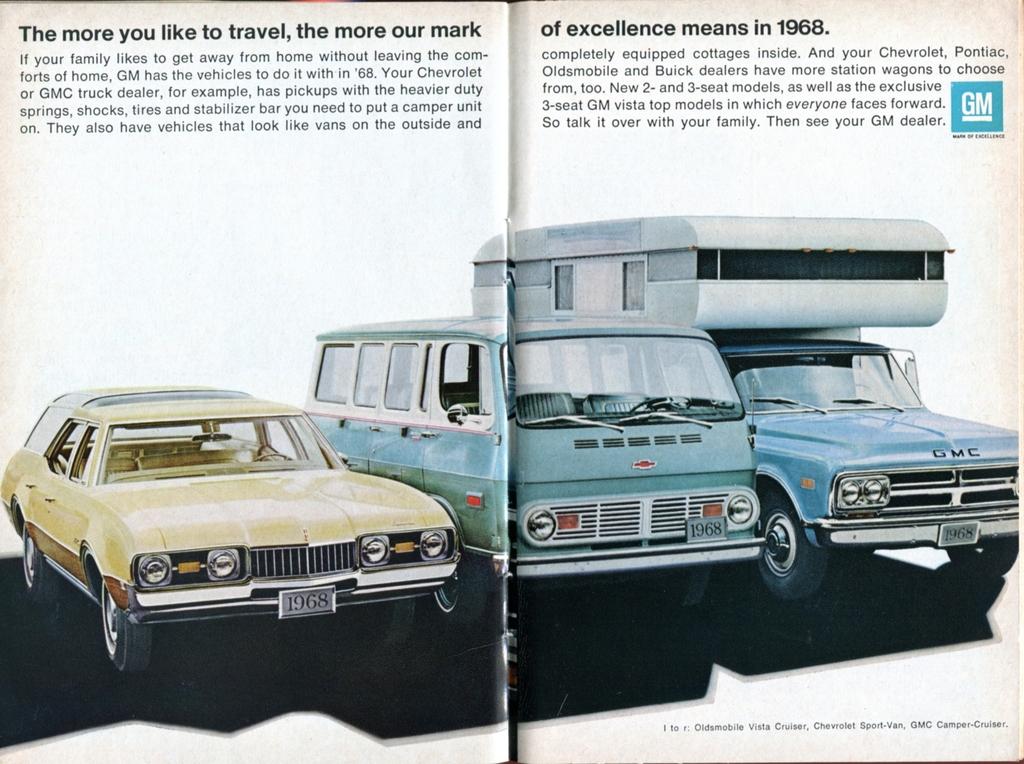What is the blue logo on the right?
Keep it short and to the point. Gm. Are these cars made by general motors?
Keep it short and to the point. Yes. 